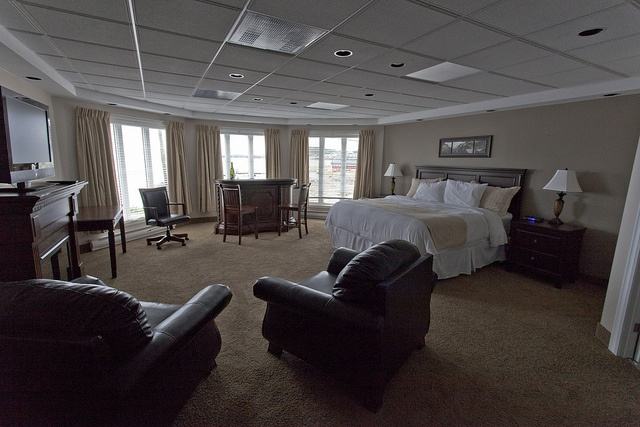Describe the objects in this image and their specific colors. I can see couch in gray, black, and darkgray tones, chair in gray, black, and darkgray tones, couch in gray, black, and darkgray tones, chair in gray, black, and darkgray tones, and bed in gray and black tones in this image. 